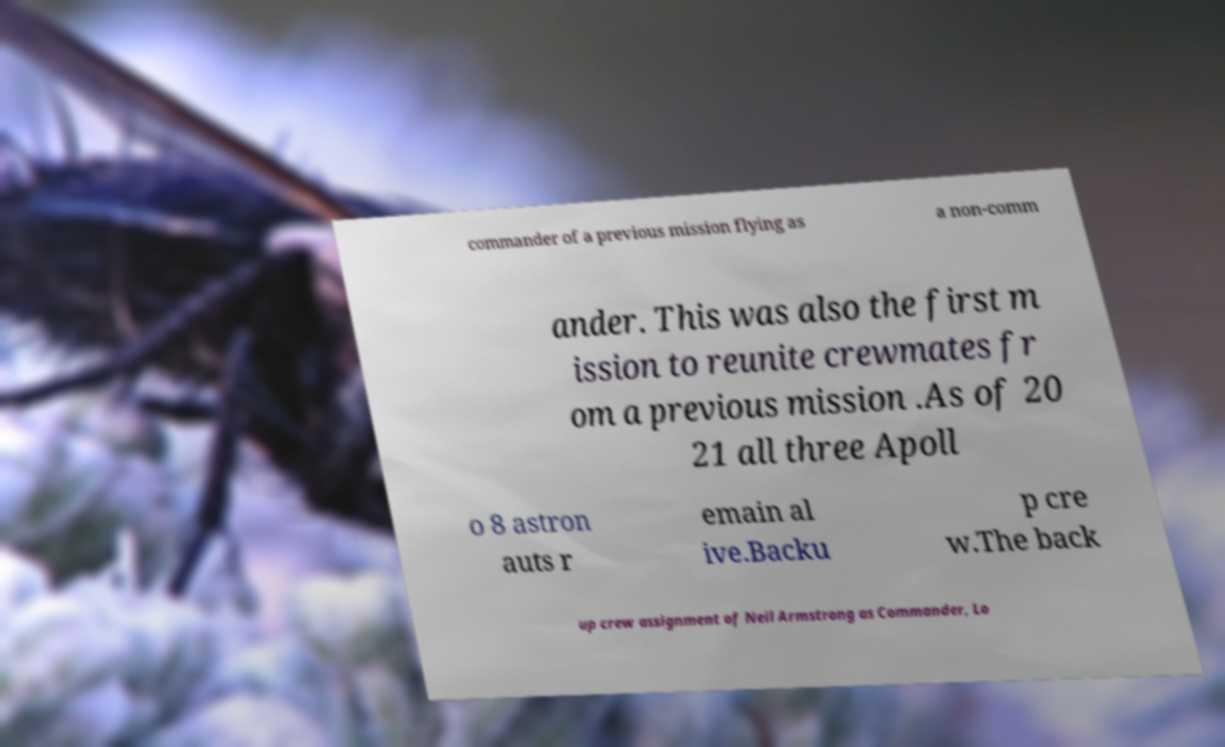Please identify and transcribe the text found in this image. commander of a previous mission flying as a non-comm ander. This was also the first m ission to reunite crewmates fr om a previous mission .As of 20 21 all three Apoll o 8 astron auts r emain al ive.Backu p cre w.The back up crew assignment of Neil Armstrong as Commander, Lo 